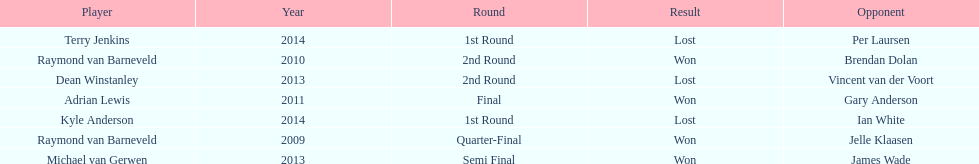Excluding kyle anderson, who were the other people that experienced losses in 2014? Terry Jenkins. 